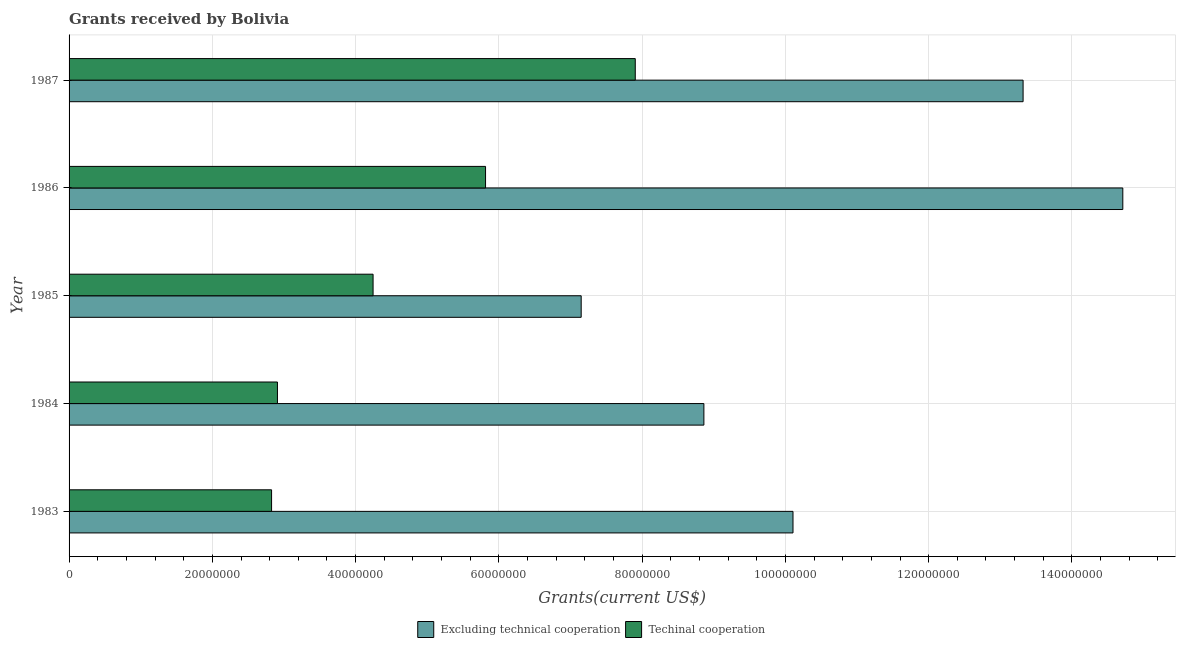How many different coloured bars are there?
Offer a terse response. 2. Are the number of bars on each tick of the Y-axis equal?
Your answer should be very brief. Yes. How many bars are there on the 4th tick from the top?
Your answer should be very brief. 2. How many bars are there on the 5th tick from the bottom?
Offer a very short reply. 2. In how many cases, is the number of bars for a given year not equal to the number of legend labels?
Provide a short and direct response. 0. What is the amount of grants received(including technical cooperation) in 1985?
Your response must be concise. 4.24e+07. Across all years, what is the maximum amount of grants received(excluding technical cooperation)?
Ensure brevity in your answer.  1.47e+08. Across all years, what is the minimum amount of grants received(including technical cooperation)?
Offer a very short reply. 2.83e+07. In which year was the amount of grants received(excluding technical cooperation) minimum?
Make the answer very short. 1985. What is the total amount of grants received(including technical cooperation) in the graph?
Give a very brief answer. 2.37e+08. What is the difference between the amount of grants received(excluding technical cooperation) in 1984 and that in 1987?
Provide a short and direct response. -4.46e+07. What is the difference between the amount of grants received(including technical cooperation) in 1984 and the amount of grants received(excluding technical cooperation) in 1983?
Ensure brevity in your answer.  -7.20e+07. What is the average amount of grants received(including technical cooperation) per year?
Your answer should be very brief. 4.74e+07. In the year 1983, what is the difference between the amount of grants received(including technical cooperation) and amount of grants received(excluding technical cooperation)?
Offer a terse response. -7.28e+07. In how many years, is the amount of grants received(excluding technical cooperation) greater than 96000000 US$?
Your response must be concise. 3. What is the ratio of the amount of grants received(including technical cooperation) in 1983 to that in 1986?
Offer a very short reply. 0.49. Is the amount of grants received(including technical cooperation) in 1984 less than that in 1987?
Your answer should be very brief. Yes. Is the difference between the amount of grants received(excluding technical cooperation) in 1985 and 1987 greater than the difference between the amount of grants received(including technical cooperation) in 1985 and 1987?
Offer a very short reply. No. What is the difference between the highest and the second highest amount of grants received(including technical cooperation)?
Keep it short and to the point. 2.09e+07. What is the difference between the highest and the lowest amount of grants received(including technical cooperation)?
Your answer should be compact. 5.08e+07. In how many years, is the amount of grants received(including technical cooperation) greater than the average amount of grants received(including technical cooperation) taken over all years?
Your response must be concise. 2. What does the 2nd bar from the top in 1984 represents?
Offer a terse response. Excluding technical cooperation. What does the 2nd bar from the bottom in 1987 represents?
Give a very brief answer. Techinal cooperation. How many bars are there?
Your answer should be compact. 10. Are all the bars in the graph horizontal?
Give a very brief answer. Yes. What is the difference between two consecutive major ticks on the X-axis?
Give a very brief answer. 2.00e+07. Does the graph contain grids?
Provide a short and direct response. Yes. How many legend labels are there?
Offer a terse response. 2. How are the legend labels stacked?
Offer a terse response. Horizontal. What is the title of the graph?
Your answer should be compact. Grants received by Bolivia. What is the label or title of the X-axis?
Give a very brief answer. Grants(current US$). What is the Grants(current US$) in Excluding technical cooperation in 1983?
Your answer should be very brief. 1.01e+08. What is the Grants(current US$) of Techinal cooperation in 1983?
Provide a short and direct response. 2.83e+07. What is the Grants(current US$) of Excluding technical cooperation in 1984?
Provide a short and direct response. 8.86e+07. What is the Grants(current US$) in Techinal cooperation in 1984?
Make the answer very short. 2.91e+07. What is the Grants(current US$) in Excluding technical cooperation in 1985?
Keep it short and to the point. 7.15e+07. What is the Grants(current US$) of Techinal cooperation in 1985?
Offer a terse response. 4.24e+07. What is the Grants(current US$) in Excluding technical cooperation in 1986?
Keep it short and to the point. 1.47e+08. What is the Grants(current US$) of Techinal cooperation in 1986?
Your answer should be compact. 5.81e+07. What is the Grants(current US$) of Excluding technical cooperation in 1987?
Ensure brevity in your answer.  1.33e+08. What is the Grants(current US$) in Techinal cooperation in 1987?
Keep it short and to the point. 7.90e+07. Across all years, what is the maximum Grants(current US$) in Excluding technical cooperation?
Your answer should be compact. 1.47e+08. Across all years, what is the maximum Grants(current US$) in Techinal cooperation?
Keep it short and to the point. 7.90e+07. Across all years, what is the minimum Grants(current US$) of Excluding technical cooperation?
Your response must be concise. 7.15e+07. Across all years, what is the minimum Grants(current US$) of Techinal cooperation?
Ensure brevity in your answer.  2.83e+07. What is the total Grants(current US$) in Excluding technical cooperation in the graph?
Offer a very short reply. 5.41e+08. What is the total Grants(current US$) in Techinal cooperation in the graph?
Keep it short and to the point. 2.37e+08. What is the difference between the Grants(current US$) in Excluding technical cooperation in 1983 and that in 1984?
Provide a succinct answer. 1.24e+07. What is the difference between the Grants(current US$) of Techinal cooperation in 1983 and that in 1984?
Your answer should be compact. -8.20e+05. What is the difference between the Grants(current US$) of Excluding technical cooperation in 1983 and that in 1985?
Your answer should be compact. 2.96e+07. What is the difference between the Grants(current US$) of Techinal cooperation in 1983 and that in 1985?
Your answer should be very brief. -1.42e+07. What is the difference between the Grants(current US$) in Excluding technical cooperation in 1983 and that in 1986?
Make the answer very short. -4.60e+07. What is the difference between the Grants(current US$) in Techinal cooperation in 1983 and that in 1986?
Give a very brief answer. -2.99e+07. What is the difference between the Grants(current US$) of Excluding technical cooperation in 1983 and that in 1987?
Your answer should be compact. -3.21e+07. What is the difference between the Grants(current US$) of Techinal cooperation in 1983 and that in 1987?
Give a very brief answer. -5.08e+07. What is the difference between the Grants(current US$) in Excluding technical cooperation in 1984 and that in 1985?
Your answer should be very brief. 1.71e+07. What is the difference between the Grants(current US$) of Techinal cooperation in 1984 and that in 1985?
Give a very brief answer. -1.34e+07. What is the difference between the Grants(current US$) in Excluding technical cooperation in 1984 and that in 1986?
Your response must be concise. -5.85e+07. What is the difference between the Grants(current US$) in Techinal cooperation in 1984 and that in 1986?
Make the answer very short. -2.90e+07. What is the difference between the Grants(current US$) of Excluding technical cooperation in 1984 and that in 1987?
Offer a very short reply. -4.46e+07. What is the difference between the Grants(current US$) of Techinal cooperation in 1984 and that in 1987?
Your answer should be compact. -5.00e+07. What is the difference between the Grants(current US$) of Excluding technical cooperation in 1985 and that in 1986?
Offer a terse response. -7.56e+07. What is the difference between the Grants(current US$) of Techinal cooperation in 1985 and that in 1986?
Make the answer very short. -1.57e+07. What is the difference between the Grants(current US$) in Excluding technical cooperation in 1985 and that in 1987?
Give a very brief answer. -6.17e+07. What is the difference between the Grants(current US$) in Techinal cooperation in 1985 and that in 1987?
Give a very brief answer. -3.66e+07. What is the difference between the Grants(current US$) in Excluding technical cooperation in 1986 and that in 1987?
Provide a short and direct response. 1.39e+07. What is the difference between the Grants(current US$) in Techinal cooperation in 1986 and that in 1987?
Offer a terse response. -2.09e+07. What is the difference between the Grants(current US$) of Excluding technical cooperation in 1983 and the Grants(current US$) of Techinal cooperation in 1984?
Make the answer very short. 7.20e+07. What is the difference between the Grants(current US$) of Excluding technical cooperation in 1983 and the Grants(current US$) of Techinal cooperation in 1985?
Provide a short and direct response. 5.86e+07. What is the difference between the Grants(current US$) in Excluding technical cooperation in 1983 and the Grants(current US$) in Techinal cooperation in 1986?
Provide a short and direct response. 4.29e+07. What is the difference between the Grants(current US$) in Excluding technical cooperation in 1983 and the Grants(current US$) in Techinal cooperation in 1987?
Offer a very short reply. 2.20e+07. What is the difference between the Grants(current US$) in Excluding technical cooperation in 1984 and the Grants(current US$) in Techinal cooperation in 1985?
Your response must be concise. 4.62e+07. What is the difference between the Grants(current US$) in Excluding technical cooperation in 1984 and the Grants(current US$) in Techinal cooperation in 1986?
Keep it short and to the point. 3.05e+07. What is the difference between the Grants(current US$) of Excluding technical cooperation in 1984 and the Grants(current US$) of Techinal cooperation in 1987?
Offer a very short reply. 9.58e+06. What is the difference between the Grants(current US$) in Excluding technical cooperation in 1985 and the Grants(current US$) in Techinal cooperation in 1986?
Your response must be concise. 1.34e+07. What is the difference between the Grants(current US$) of Excluding technical cooperation in 1985 and the Grants(current US$) of Techinal cooperation in 1987?
Provide a succinct answer. -7.55e+06. What is the difference between the Grants(current US$) in Excluding technical cooperation in 1986 and the Grants(current US$) in Techinal cooperation in 1987?
Offer a very short reply. 6.81e+07. What is the average Grants(current US$) in Excluding technical cooperation per year?
Your answer should be compact. 1.08e+08. What is the average Grants(current US$) of Techinal cooperation per year?
Provide a short and direct response. 4.74e+07. In the year 1983, what is the difference between the Grants(current US$) of Excluding technical cooperation and Grants(current US$) of Techinal cooperation?
Your response must be concise. 7.28e+07. In the year 1984, what is the difference between the Grants(current US$) of Excluding technical cooperation and Grants(current US$) of Techinal cooperation?
Your response must be concise. 5.95e+07. In the year 1985, what is the difference between the Grants(current US$) of Excluding technical cooperation and Grants(current US$) of Techinal cooperation?
Your answer should be very brief. 2.90e+07. In the year 1986, what is the difference between the Grants(current US$) in Excluding technical cooperation and Grants(current US$) in Techinal cooperation?
Offer a terse response. 8.90e+07. In the year 1987, what is the difference between the Grants(current US$) of Excluding technical cooperation and Grants(current US$) of Techinal cooperation?
Make the answer very short. 5.41e+07. What is the ratio of the Grants(current US$) in Excluding technical cooperation in 1983 to that in 1984?
Ensure brevity in your answer.  1.14. What is the ratio of the Grants(current US$) of Techinal cooperation in 1983 to that in 1984?
Give a very brief answer. 0.97. What is the ratio of the Grants(current US$) in Excluding technical cooperation in 1983 to that in 1985?
Offer a terse response. 1.41. What is the ratio of the Grants(current US$) of Techinal cooperation in 1983 to that in 1985?
Your answer should be very brief. 0.67. What is the ratio of the Grants(current US$) in Excluding technical cooperation in 1983 to that in 1986?
Keep it short and to the point. 0.69. What is the ratio of the Grants(current US$) in Techinal cooperation in 1983 to that in 1986?
Your answer should be very brief. 0.49. What is the ratio of the Grants(current US$) of Excluding technical cooperation in 1983 to that in 1987?
Provide a short and direct response. 0.76. What is the ratio of the Grants(current US$) in Techinal cooperation in 1983 to that in 1987?
Ensure brevity in your answer.  0.36. What is the ratio of the Grants(current US$) of Excluding technical cooperation in 1984 to that in 1985?
Offer a terse response. 1.24. What is the ratio of the Grants(current US$) of Techinal cooperation in 1984 to that in 1985?
Offer a very short reply. 0.69. What is the ratio of the Grants(current US$) of Excluding technical cooperation in 1984 to that in 1986?
Provide a succinct answer. 0.6. What is the ratio of the Grants(current US$) of Techinal cooperation in 1984 to that in 1986?
Give a very brief answer. 0.5. What is the ratio of the Grants(current US$) of Excluding technical cooperation in 1984 to that in 1987?
Your answer should be compact. 0.67. What is the ratio of the Grants(current US$) in Techinal cooperation in 1984 to that in 1987?
Keep it short and to the point. 0.37. What is the ratio of the Grants(current US$) in Excluding technical cooperation in 1985 to that in 1986?
Ensure brevity in your answer.  0.49. What is the ratio of the Grants(current US$) in Techinal cooperation in 1985 to that in 1986?
Your answer should be compact. 0.73. What is the ratio of the Grants(current US$) in Excluding technical cooperation in 1985 to that in 1987?
Offer a terse response. 0.54. What is the ratio of the Grants(current US$) of Techinal cooperation in 1985 to that in 1987?
Make the answer very short. 0.54. What is the ratio of the Grants(current US$) of Excluding technical cooperation in 1986 to that in 1987?
Offer a terse response. 1.1. What is the ratio of the Grants(current US$) in Techinal cooperation in 1986 to that in 1987?
Offer a terse response. 0.74. What is the difference between the highest and the second highest Grants(current US$) in Excluding technical cooperation?
Give a very brief answer. 1.39e+07. What is the difference between the highest and the second highest Grants(current US$) in Techinal cooperation?
Ensure brevity in your answer.  2.09e+07. What is the difference between the highest and the lowest Grants(current US$) in Excluding technical cooperation?
Your response must be concise. 7.56e+07. What is the difference between the highest and the lowest Grants(current US$) of Techinal cooperation?
Offer a very short reply. 5.08e+07. 